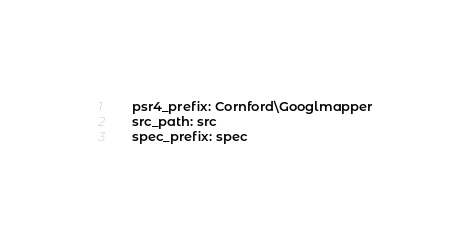<code> <loc_0><loc_0><loc_500><loc_500><_YAML_>    psr4_prefix: Cornford\Googlmapper
    src_path: src
    spec_prefix: spec</code> 